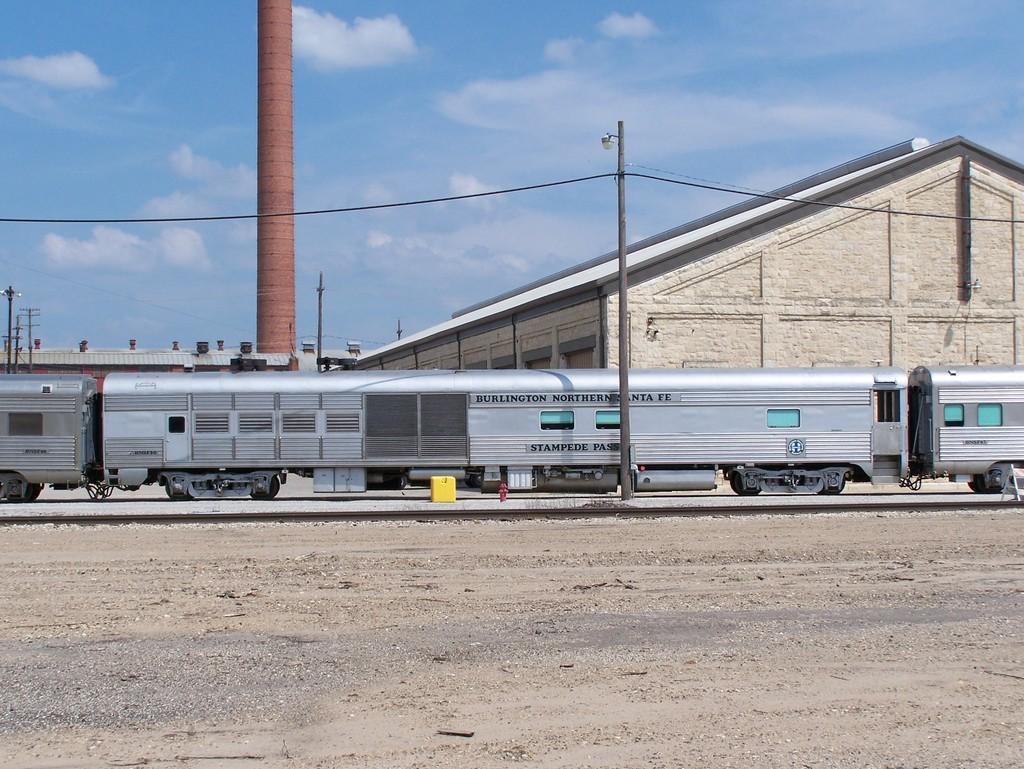In one or two sentences, can you explain what this image depicts? In this image we can see poles, sheds, train, cloudy sky and things. 